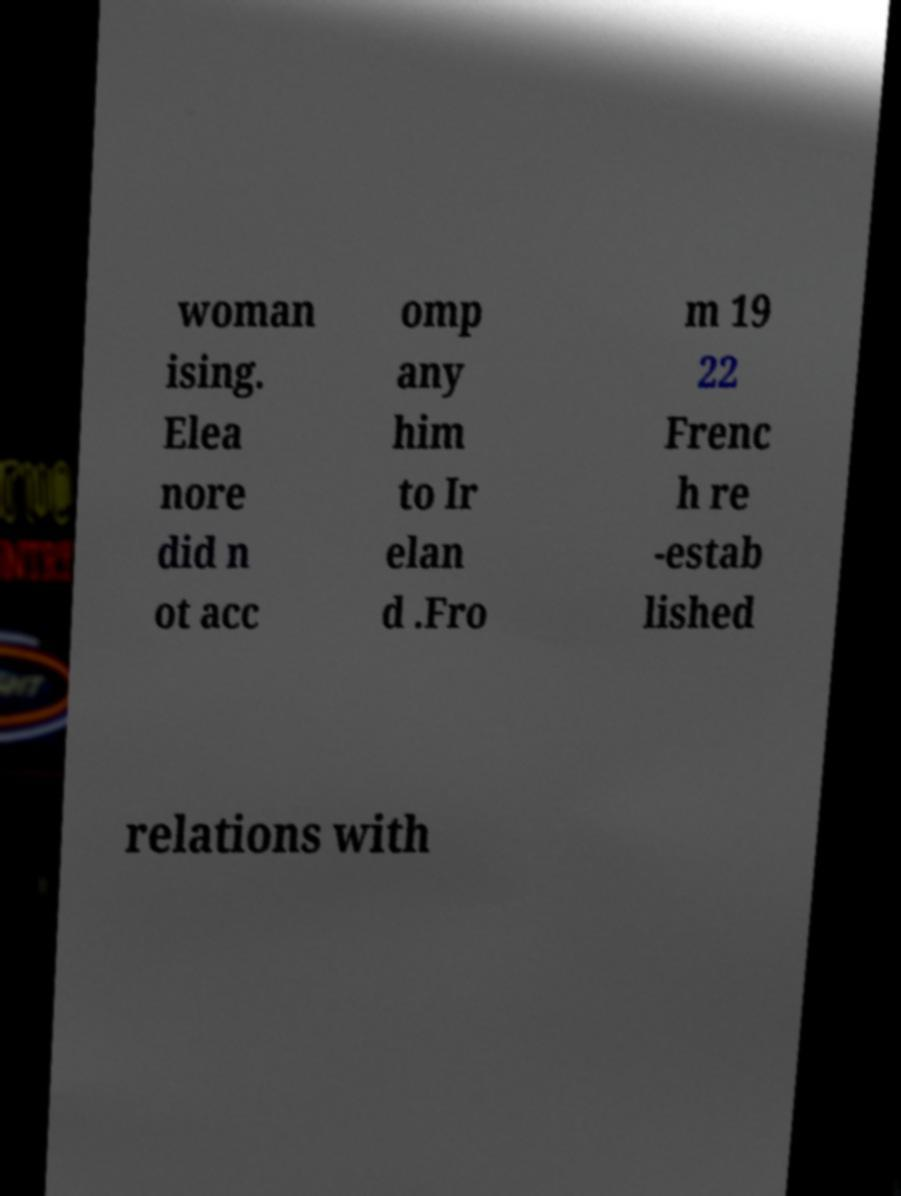Could you extract and type out the text from this image? woman ising. Elea nore did n ot acc omp any him to Ir elan d .Fro m 19 22 Frenc h re -estab lished relations with 